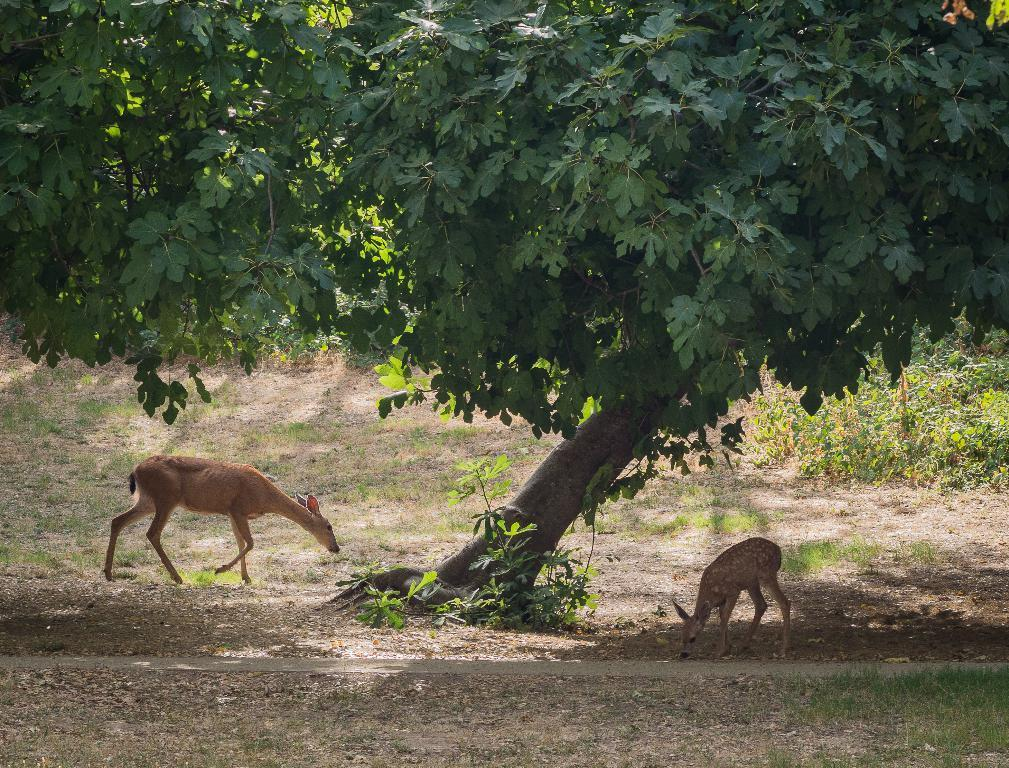What animals can be seen in the image? There are two deers in the image. What type of vegetation is present in the image? There are plants in the image. Can you describe the tree in the image? There is a tree with branches and leaves in the image. How many planes can be seen flying over the deers in the image? There are no planes visible in the image; it only features two deers, plants, and a tree. 